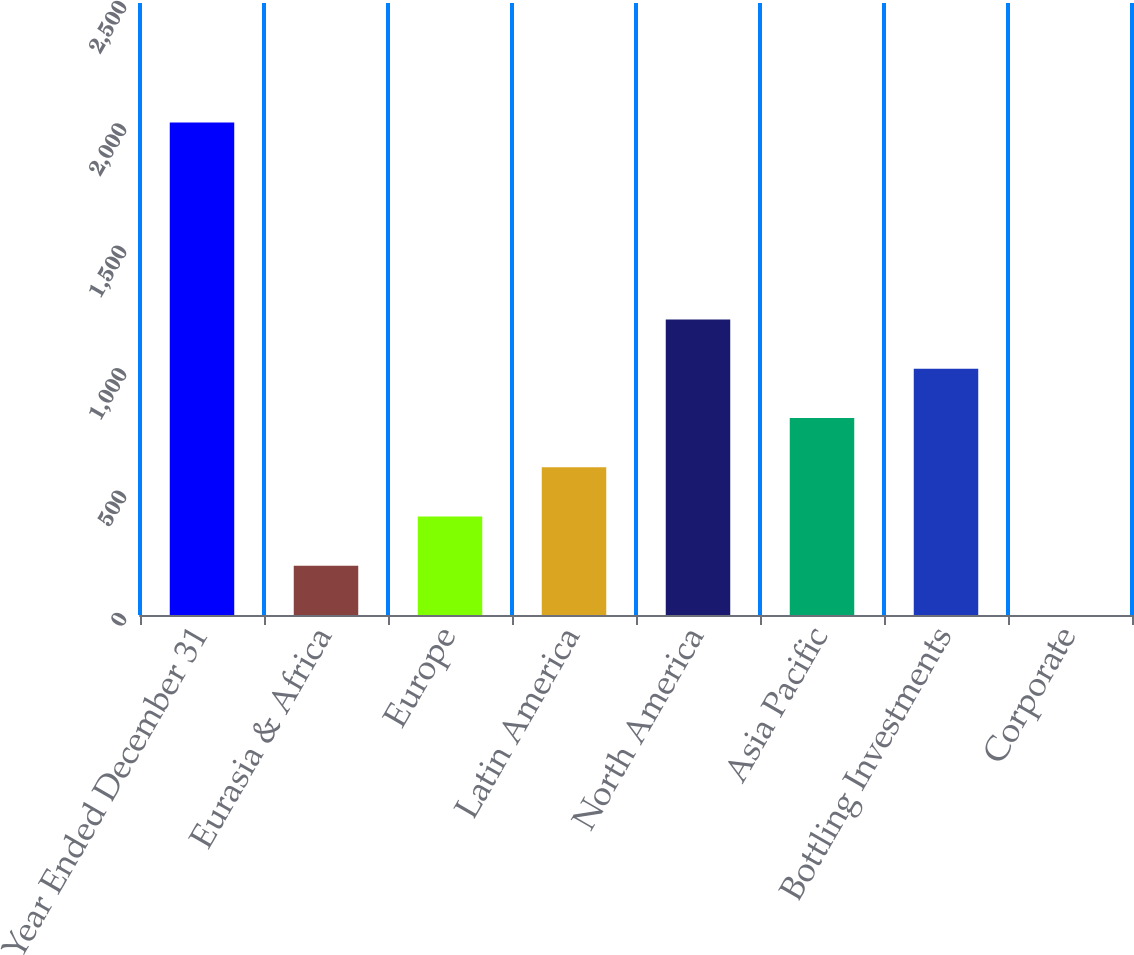Convert chart to OTSL. <chart><loc_0><loc_0><loc_500><loc_500><bar_chart><fcel>Year Ended December 31<fcel>Eurasia & Africa<fcel>Europe<fcel>Latin America<fcel>North America<fcel>Asia Pacific<fcel>Bottling Investments<fcel>Corporate<nl><fcel>2012<fcel>201.47<fcel>402.64<fcel>603.81<fcel>1207.32<fcel>804.98<fcel>1006.15<fcel>0.3<nl></chart> 